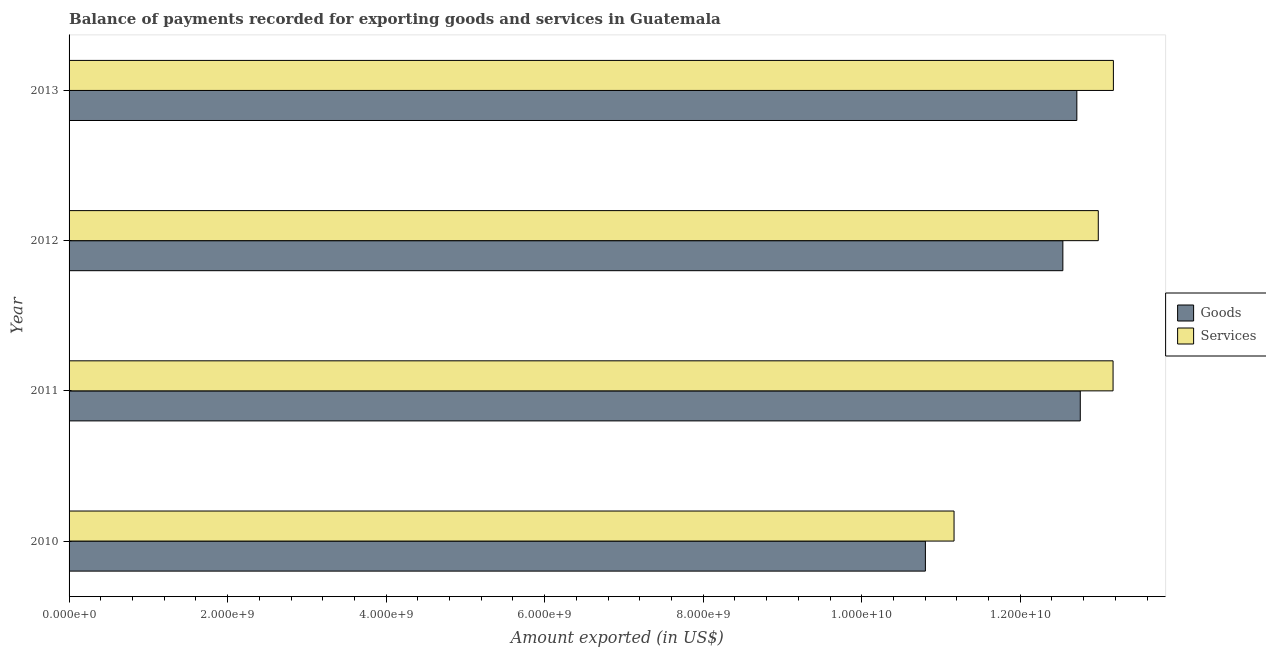How many different coloured bars are there?
Make the answer very short. 2. How many groups of bars are there?
Your response must be concise. 4. Are the number of bars per tick equal to the number of legend labels?
Make the answer very short. Yes. How many bars are there on the 3rd tick from the bottom?
Offer a very short reply. 2. What is the label of the 4th group of bars from the top?
Offer a terse response. 2010. In how many cases, is the number of bars for a given year not equal to the number of legend labels?
Offer a very short reply. 0. What is the amount of services exported in 2013?
Ensure brevity in your answer.  1.32e+1. Across all years, what is the maximum amount of goods exported?
Keep it short and to the point. 1.28e+1. Across all years, what is the minimum amount of goods exported?
Offer a terse response. 1.08e+1. In which year was the amount of services exported minimum?
Make the answer very short. 2010. What is the total amount of services exported in the graph?
Your response must be concise. 5.05e+1. What is the difference between the amount of goods exported in 2010 and that in 2012?
Your answer should be compact. -1.73e+09. What is the difference between the amount of services exported in 2010 and the amount of goods exported in 2011?
Ensure brevity in your answer.  -1.59e+09. What is the average amount of services exported per year?
Ensure brevity in your answer.  1.26e+1. In the year 2013, what is the difference between the amount of goods exported and amount of services exported?
Your answer should be very brief. -4.61e+08. In how many years, is the amount of goods exported greater than 8000000000 US$?
Provide a succinct answer. 4. What is the ratio of the amount of goods exported in 2010 to that in 2012?
Provide a succinct answer. 0.86. Is the amount of goods exported in 2012 less than that in 2013?
Your answer should be compact. Yes. What is the difference between the highest and the second highest amount of goods exported?
Your response must be concise. 4.33e+07. What is the difference between the highest and the lowest amount of services exported?
Offer a very short reply. 2.01e+09. In how many years, is the amount of goods exported greater than the average amount of goods exported taken over all years?
Give a very brief answer. 3. Is the sum of the amount of services exported in 2010 and 2011 greater than the maximum amount of goods exported across all years?
Offer a terse response. Yes. What does the 2nd bar from the top in 2011 represents?
Ensure brevity in your answer.  Goods. What does the 1st bar from the bottom in 2013 represents?
Keep it short and to the point. Goods. How many bars are there?
Provide a succinct answer. 8. How many years are there in the graph?
Offer a terse response. 4. What is the difference between two consecutive major ticks on the X-axis?
Your answer should be compact. 2.00e+09. Does the graph contain any zero values?
Give a very brief answer. No. Does the graph contain grids?
Your answer should be compact. No. Where does the legend appear in the graph?
Provide a short and direct response. Center right. How are the legend labels stacked?
Provide a succinct answer. Vertical. What is the title of the graph?
Offer a very short reply. Balance of payments recorded for exporting goods and services in Guatemala. What is the label or title of the X-axis?
Provide a succinct answer. Amount exported (in US$). What is the Amount exported (in US$) in Goods in 2010?
Offer a very short reply. 1.08e+1. What is the Amount exported (in US$) of Services in 2010?
Your answer should be very brief. 1.12e+1. What is the Amount exported (in US$) of Goods in 2011?
Give a very brief answer. 1.28e+1. What is the Amount exported (in US$) of Services in 2011?
Your response must be concise. 1.32e+1. What is the Amount exported (in US$) of Goods in 2012?
Offer a very short reply. 1.25e+1. What is the Amount exported (in US$) in Services in 2012?
Your response must be concise. 1.30e+1. What is the Amount exported (in US$) in Goods in 2013?
Give a very brief answer. 1.27e+1. What is the Amount exported (in US$) of Services in 2013?
Offer a very short reply. 1.32e+1. Across all years, what is the maximum Amount exported (in US$) in Goods?
Provide a succinct answer. 1.28e+1. Across all years, what is the maximum Amount exported (in US$) of Services?
Ensure brevity in your answer.  1.32e+1. Across all years, what is the minimum Amount exported (in US$) of Goods?
Ensure brevity in your answer.  1.08e+1. Across all years, what is the minimum Amount exported (in US$) of Services?
Your response must be concise. 1.12e+1. What is the total Amount exported (in US$) in Goods in the graph?
Keep it short and to the point. 4.88e+1. What is the total Amount exported (in US$) in Services in the graph?
Provide a succinct answer. 5.05e+1. What is the difference between the Amount exported (in US$) of Goods in 2010 and that in 2011?
Provide a succinct answer. -1.95e+09. What is the difference between the Amount exported (in US$) in Services in 2010 and that in 2011?
Your answer should be very brief. -2.01e+09. What is the difference between the Amount exported (in US$) in Goods in 2010 and that in 2012?
Give a very brief answer. -1.73e+09. What is the difference between the Amount exported (in US$) of Services in 2010 and that in 2012?
Keep it short and to the point. -1.82e+09. What is the difference between the Amount exported (in US$) of Goods in 2010 and that in 2013?
Provide a succinct answer. -1.91e+09. What is the difference between the Amount exported (in US$) in Services in 2010 and that in 2013?
Ensure brevity in your answer.  -2.01e+09. What is the difference between the Amount exported (in US$) in Goods in 2011 and that in 2012?
Keep it short and to the point. 2.20e+08. What is the difference between the Amount exported (in US$) in Services in 2011 and that in 2012?
Your answer should be compact. 1.86e+08. What is the difference between the Amount exported (in US$) of Goods in 2011 and that in 2013?
Provide a short and direct response. 4.33e+07. What is the difference between the Amount exported (in US$) of Services in 2011 and that in 2013?
Provide a short and direct response. -4.09e+06. What is the difference between the Amount exported (in US$) in Goods in 2012 and that in 2013?
Your answer should be very brief. -1.77e+08. What is the difference between the Amount exported (in US$) in Services in 2012 and that in 2013?
Keep it short and to the point. -1.90e+08. What is the difference between the Amount exported (in US$) of Goods in 2010 and the Amount exported (in US$) of Services in 2011?
Offer a terse response. -2.37e+09. What is the difference between the Amount exported (in US$) of Goods in 2010 and the Amount exported (in US$) of Services in 2012?
Provide a succinct answer. -2.18e+09. What is the difference between the Amount exported (in US$) of Goods in 2010 and the Amount exported (in US$) of Services in 2013?
Keep it short and to the point. -2.37e+09. What is the difference between the Amount exported (in US$) of Goods in 2011 and the Amount exported (in US$) of Services in 2012?
Your answer should be compact. -2.27e+08. What is the difference between the Amount exported (in US$) of Goods in 2011 and the Amount exported (in US$) of Services in 2013?
Your answer should be compact. -4.18e+08. What is the difference between the Amount exported (in US$) in Goods in 2012 and the Amount exported (in US$) in Services in 2013?
Your response must be concise. -6.37e+08. What is the average Amount exported (in US$) in Goods per year?
Give a very brief answer. 1.22e+1. What is the average Amount exported (in US$) of Services per year?
Your answer should be very brief. 1.26e+1. In the year 2010, what is the difference between the Amount exported (in US$) in Goods and Amount exported (in US$) in Services?
Give a very brief answer. -3.62e+08. In the year 2011, what is the difference between the Amount exported (in US$) in Goods and Amount exported (in US$) in Services?
Offer a terse response. -4.14e+08. In the year 2012, what is the difference between the Amount exported (in US$) in Goods and Amount exported (in US$) in Services?
Provide a short and direct response. -4.47e+08. In the year 2013, what is the difference between the Amount exported (in US$) of Goods and Amount exported (in US$) of Services?
Your response must be concise. -4.61e+08. What is the ratio of the Amount exported (in US$) in Goods in 2010 to that in 2011?
Your response must be concise. 0.85. What is the ratio of the Amount exported (in US$) in Services in 2010 to that in 2011?
Keep it short and to the point. 0.85. What is the ratio of the Amount exported (in US$) in Goods in 2010 to that in 2012?
Provide a succinct answer. 0.86. What is the ratio of the Amount exported (in US$) of Services in 2010 to that in 2012?
Provide a short and direct response. 0.86. What is the ratio of the Amount exported (in US$) of Goods in 2010 to that in 2013?
Offer a terse response. 0.85. What is the ratio of the Amount exported (in US$) in Services in 2010 to that in 2013?
Provide a short and direct response. 0.85. What is the ratio of the Amount exported (in US$) in Goods in 2011 to that in 2012?
Make the answer very short. 1.02. What is the ratio of the Amount exported (in US$) in Services in 2011 to that in 2012?
Offer a very short reply. 1.01. What is the ratio of the Amount exported (in US$) in Services in 2011 to that in 2013?
Provide a short and direct response. 1. What is the ratio of the Amount exported (in US$) of Goods in 2012 to that in 2013?
Your response must be concise. 0.99. What is the ratio of the Amount exported (in US$) of Services in 2012 to that in 2013?
Offer a very short reply. 0.99. What is the difference between the highest and the second highest Amount exported (in US$) of Goods?
Provide a short and direct response. 4.33e+07. What is the difference between the highest and the second highest Amount exported (in US$) in Services?
Offer a terse response. 4.09e+06. What is the difference between the highest and the lowest Amount exported (in US$) in Goods?
Make the answer very short. 1.95e+09. What is the difference between the highest and the lowest Amount exported (in US$) in Services?
Offer a very short reply. 2.01e+09. 